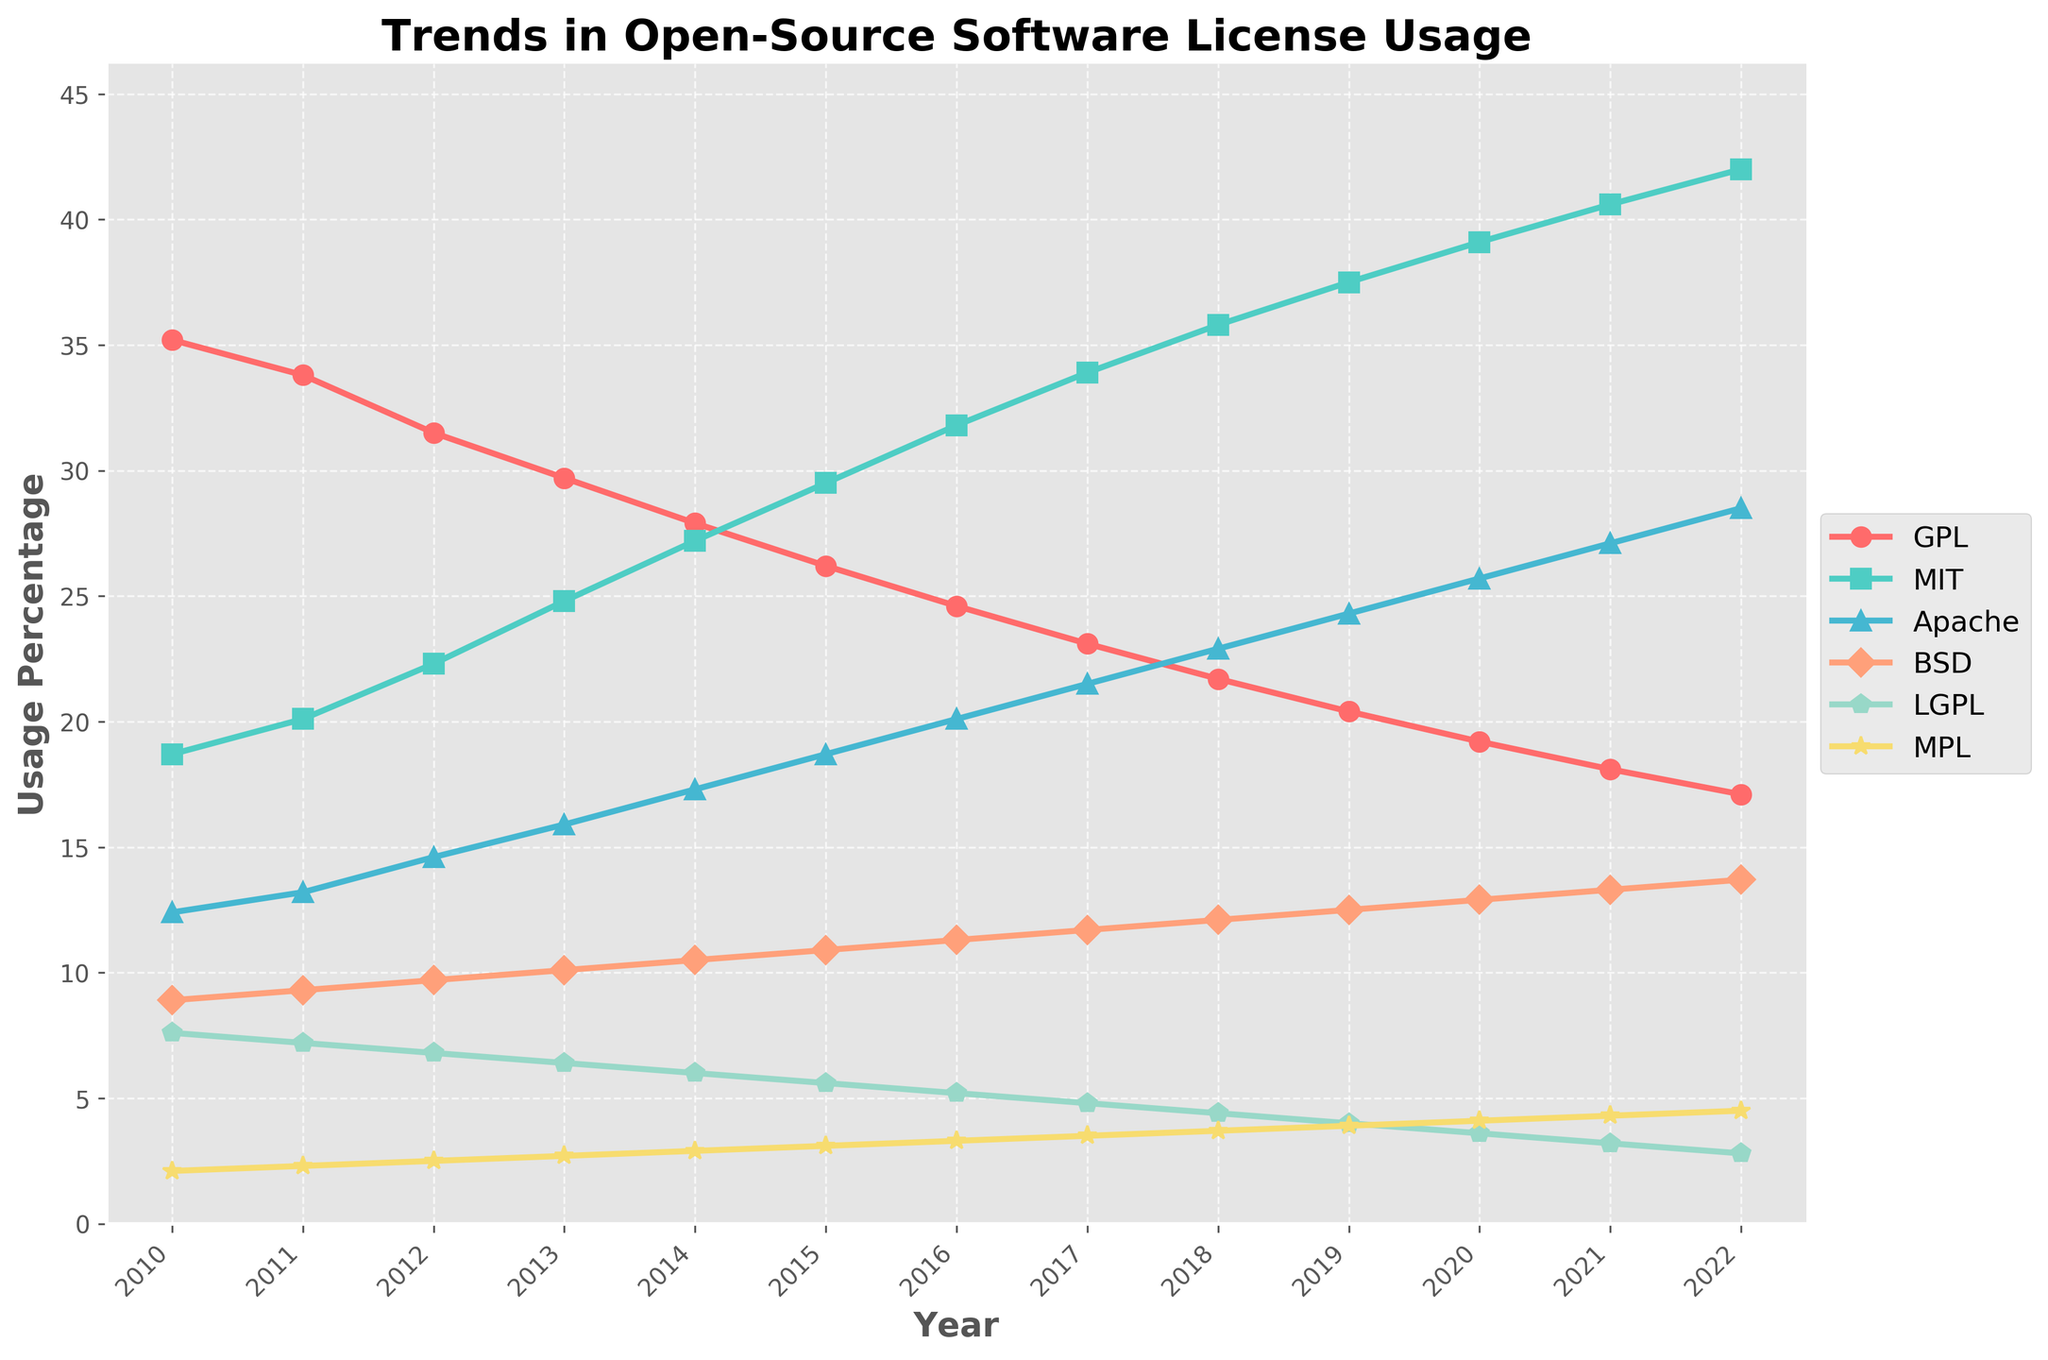When did MIT licenses become more popular than GPL licenses? First, look at the lines representing the GPL and MIT licenses. Find the point where the MIT line crosses above the GPL line. This happens between 2014 and 2015. Verify that from 2015 onward, MIT percentages are higher than GPL.
Answer: Between 2014 and 2015 Which year had the maximum usage of the MIT license? Identify the highest point on the MIT license line. The peak of the MIT percentage line is in 2022.
Answer: 2022 What is the difference between the usage of Apache and BSD licenses in 2021? Locate the values for Apache and BSD licenses in 2021. Apache is at 27.1% and BSD is at 13.3%. Calculate the difference by subtracting BSD from Apache: 27.1 - 13.3.
Answer: 13.8 Which license had the least growth in popularity from 2010 to 2022? Calculate the growth for each license by subtracting the 2010 usage percentage from the 2022 usage percentage. MPL grows from 2.1 to 4.5, GPL decreases from 35.2 to 17.1, MIT grows from 18.7 to 42, Apache grows from 12.4 to 28.5, BSD grows from 8.9 to 13.7, LGPL decreases from 7.6 to 2.8. The LGPL shows the least growth as its usage decreased.
Answer: LGPL Compare the trend of MPL and BSD licenses from 2010 to 2022. Observe both lines representing the MPL and BSD licenses. MPL shows a gradual increase from 2.1 to 4.5, and BSD shows a steady but less pronounced increase from 8.9 to 13.7. MPL's trend is more consistent, while BSD’s trend has minor fluctuations.
Answer: MPL trends consistently, BSD trends with fluctuations What is the average usage percentage of the GPL license from 2010 to 2022? Sum the usage percentages for the GPL license from each year and divide by the number of years. (35.2 + 33.8 + 31.5 + 29.7 + 27.9 + 26.2 + 24.6 + 23.1 + 21.7 + 20.4 + 19.2 + 18.1 + 17.1) / 13.
Answer: 25.9% How did the usage percentage of the MIT license change from 2016 to 2019? Note the percentages for MIT in 2016 (31.8) and 2019 (37.5). Subtract the 2016 value from the 2019 value to find the change: 37.5 - 31.8.
Answer: Increased by 5.7 Which license had the highest usage percentage in 2022? Find the maximum value among the license percentages in 2022. MIT, with 42%, has the highest.
Answer: MIT What is the combined usage percentage of Apache and MPL licenses in 2020? Add the percentages of Apache and MPL for 2020: 25.7 (Apache) + 4.1 (MPL).
Answer: 29.8 Compare license trends and state which license consistently lost popularity from 2010 to 2022. Observe each license’s trend line. The GPL license consistently decreases from 35.2 in 2010 to 17.1 in 2022.
Answer: GPL 